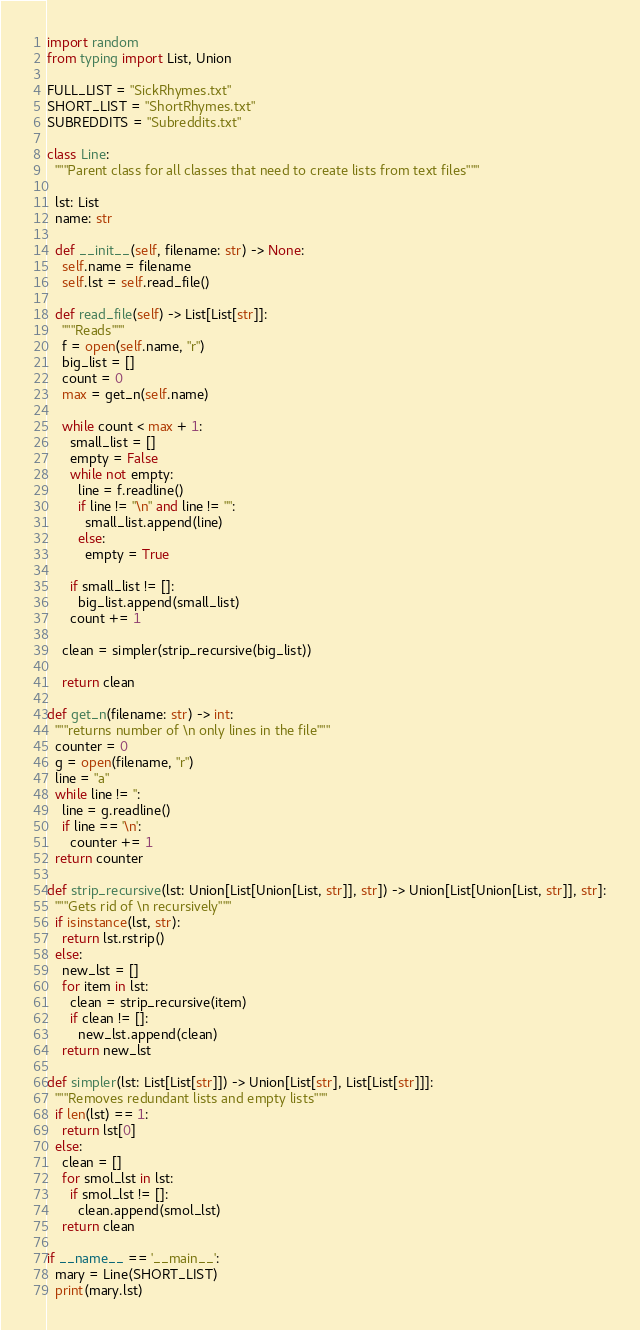<code> <loc_0><loc_0><loc_500><loc_500><_Python_>import random
from typing import List, Union

FULL_LIST = "SickRhymes.txt"
SHORT_LIST = "ShortRhymes.txt"
SUBREDDITS = "Subreddits.txt"

class Line:
  """Parent class for all classes that need to create lists from text files"""

  lst: List
  name: str
  
  def __init__(self, filename: str) -> None:
    self.name = filename
    self.lst = self.read_file()
        
  def read_file(self) -> List[List[str]]:
    """Reads"""
    f = open(self.name, "r")
    big_list = []
    count = 0
    max = get_n(self.name)
    
    while count < max + 1:
      small_list = []
      empty = False
      while not empty:
        line = f.readline()
        if line != "\n" and line != "":
          small_list.append(line)
        else:
          empty = True
      
      if small_list != []:
        big_list.append(small_list)
      count += 1

    clean = simpler(strip_recursive(big_list))
    
    return clean

def get_n(filename: str) -> int:
  """returns number of \n only lines in the file"""
  counter = 0
  g = open(filename, "r")
  line = "a"
  while line != '':
    line = g.readline()
    if line == '\n':
      counter += 1
  return counter
  
def strip_recursive(lst: Union[List[Union[List, str]], str]) -> Union[List[Union[List, str]], str]:
  """Gets rid of \n recursively"""
  if isinstance(lst, str):
    return lst.rstrip()
  else:
    new_lst = []
    for item in lst:
      clean = strip_recursive(item)
      if clean != []:
        new_lst.append(clean)
    return new_lst

def simpler(lst: List[List[str]]) -> Union[List[str], List[List[str]]]:
  """Removes redundant lists and empty lists"""
  if len(lst) == 1:
    return lst[0]
  else:
    clean = []
    for smol_lst in lst:
      if smol_lst != []:
        clean.append(smol_lst)
    return clean

if __name__ == '__main__':
  mary = Line(SHORT_LIST)
  print(mary.lst)
</code> 